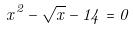<formula> <loc_0><loc_0><loc_500><loc_500>x ^ { 2 } - \sqrt { x } - 1 4 = 0</formula> 